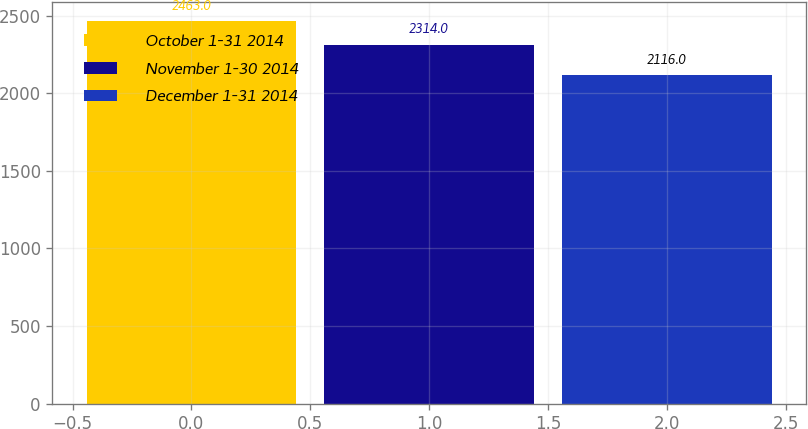<chart> <loc_0><loc_0><loc_500><loc_500><bar_chart><fcel>October 1-31 2014<fcel>November 1-30 2014<fcel>December 1-31 2014<nl><fcel>2463<fcel>2314<fcel>2116<nl></chart> 